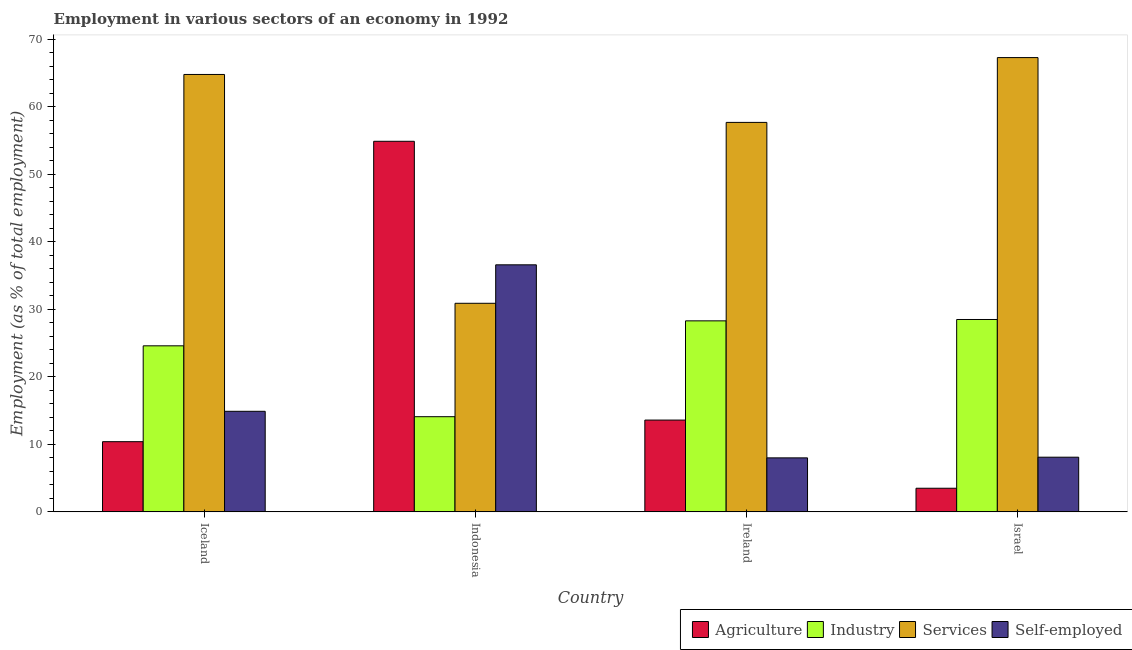Are the number of bars per tick equal to the number of legend labels?
Ensure brevity in your answer.  Yes. Are the number of bars on each tick of the X-axis equal?
Your answer should be compact. Yes. How many bars are there on the 3rd tick from the left?
Ensure brevity in your answer.  4. What is the label of the 4th group of bars from the left?
Your answer should be very brief. Israel. In how many cases, is the number of bars for a given country not equal to the number of legend labels?
Offer a very short reply. 0. What is the percentage of self employed workers in Iceland?
Your response must be concise. 14.9. Across all countries, what is the maximum percentage of workers in services?
Your answer should be compact. 67.3. Across all countries, what is the minimum percentage of workers in services?
Offer a very short reply. 30.9. In which country was the percentage of self employed workers maximum?
Provide a short and direct response. Indonesia. In which country was the percentage of workers in agriculture minimum?
Make the answer very short. Israel. What is the total percentage of workers in agriculture in the graph?
Ensure brevity in your answer.  82.4. What is the difference between the percentage of workers in services in Indonesia and that in Ireland?
Make the answer very short. -26.8. What is the difference between the percentage of workers in agriculture in Iceland and the percentage of workers in services in Ireland?
Provide a short and direct response. -47.3. What is the average percentage of self employed workers per country?
Provide a succinct answer. 16.9. What is the difference between the percentage of workers in industry and percentage of self employed workers in Ireland?
Ensure brevity in your answer.  20.3. In how many countries, is the percentage of workers in services greater than 16 %?
Keep it short and to the point. 4. What is the ratio of the percentage of workers in industry in Ireland to that in Israel?
Ensure brevity in your answer.  0.99. Is the difference between the percentage of workers in industry in Iceland and Israel greater than the difference between the percentage of workers in services in Iceland and Israel?
Make the answer very short. No. What is the difference between the highest and the second highest percentage of workers in industry?
Offer a terse response. 0.2. What is the difference between the highest and the lowest percentage of workers in agriculture?
Provide a short and direct response. 51.4. Is it the case that in every country, the sum of the percentage of workers in industry and percentage of workers in agriculture is greater than the sum of percentage of workers in services and percentage of self employed workers?
Offer a very short reply. No. What does the 4th bar from the left in Ireland represents?
Offer a very short reply. Self-employed. What does the 2nd bar from the right in Israel represents?
Provide a short and direct response. Services. Are all the bars in the graph horizontal?
Provide a succinct answer. No. Are the values on the major ticks of Y-axis written in scientific E-notation?
Your response must be concise. No. Does the graph contain any zero values?
Give a very brief answer. No. Does the graph contain grids?
Offer a very short reply. No. What is the title of the graph?
Provide a succinct answer. Employment in various sectors of an economy in 1992. Does "SF6 gas" appear as one of the legend labels in the graph?
Make the answer very short. No. What is the label or title of the Y-axis?
Your answer should be very brief. Employment (as % of total employment). What is the Employment (as % of total employment) of Agriculture in Iceland?
Offer a very short reply. 10.4. What is the Employment (as % of total employment) in Industry in Iceland?
Your answer should be very brief. 24.6. What is the Employment (as % of total employment) of Services in Iceland?
Offer a very short reply. 64.8. What is the Employment (as % of total employment) in Self-employed in Iceland?
Your answer should be very brief. 14.9. What is the Employment (as % of total employment) in Agriculture in Indonesia?
Provide a short and direct response. 54.9. What is the Employment (as % of total employment) in Industry in Indonesia?
Ensure brevity in your answer.  14.1. What is the Employment (as % of total employment) of Services in Indonesia?
Your answer should be very brief. 30.9. What is the Employment (as % of total employment) in Self-employed in Indonesia?
Offer a terse response. 36.6. What is the Employment (as % of total employment) in Agriculture in Ireland?
Keep it short and to the point. 13.6. What is the Employment (as % of total employment) in Industry in Ireland?
Provide a succinct answer. 28.3. What is the Employment (as % of total employment) in Services in Ireland?
Offer a terse response. 57.7. What is the Employment (as % of total employment) of Self-employed in Ireland?
Make the answer very short. 8. What is the Employment (as % of total employment) of Agriculture in Israel?
Offer a terse response. 3.5. What is the Employment (as % of total employment) in Industry in Israel?
Ensure brevity in your answer.  28.5. What is the Employment (as % of total employment) in Services in Israel?
Offer a terse response. 67.3. What is the Employment (as % of total employment) in Self-employed in Israel?
Your answer should be very brief. 8.1. Across all countries, what is the maximum Employment (as % of total employment) of Agriculture?
Provide a short and direct response. 54.9. Across all countries, what is the maximum Employment (as % of total employment) in Services?
Keep it short and to the point. 67.3. Across all countries, what is the maximum Employment (as % of total employment) of Self-employed?
Keep it short and to the point. 36.6. Across all countries, what is the minimum Employment (as % of total employment) in Industry?
Ensure brevity in your answer.  14.1. Across all countries, what is the minimum Employment (as % of total employment) in Services?
Offer a very short reply. 30.9. Across all countries, what is the minimum Employment (as % of total employment) in Self-employed?
Your answer should be compact. 8. What is the total Employment (as % of total employment) of Agriculture in the graph?
Give a very brief answer. 82.4. What is the total Employment (as % of total employment) of Industry in the graph?
Ensure brevity in your answer.  95.5. What is the total Employment (as % of total employment) of Services in the graph?
Your response must be concise. 220.7. What is the total Employment (as % of total employment) of Self-employed in the graph?
Offer a very short reply. 67.6. What is the difference between the Employment (as % of total employment) in Agriculture in Iceland and that in Indonesia?
Provide a succinct answer. -44.5. What is the difference between the Employment (as % of total employment) in Industry in Iceland and that in Indonesia?
Your answer should be very brief. 10.5. What is the difference between the Employment (as % of total employment) in Services in Iceland and that in Indonesia?
Keep it short and to the point. 33.9. What is the difference between the Employment (as % of total employment) of Self-employed in Iceland and that in Indonesia?
Give a very brief answer. -21.7. What is the difference between the Employment (as % of total employment) of Agriculture in Iceland and that in Ireland?
Keep it short and to the point. -3.2. What is the difference between the Employment (as % of total employment) of Services in Iceland and that in Ireland?
Make the answer very short. 7.1. What is the difference between the Employment (as % of total employment) of Self-employed in Iceland and that in Ireland?
Your response must be concise. 6.9. What is the difference between the Employment (as % of total employment) in Industry in Iceland and that in Israel?
Offer a very short reply. -3.9. What is the difference between the Employment (as % of total employment) in Services in Iceland and that in Israel?
Give a very brief answer. -2.5. What is the difference between the Employment (as % of total employment) in Self-employed in Iceland and that in Israel?
Make the answer very short. 6.8. What is the difference between the Employment (as % of total employment) in Agriculture in Indonesia and that in Ireland?
Your answer should be very brief. 41.3. What is the difference between the Employment (as % of total employment) of Industry in Indonesia and that in Ireland?
Provide a succinct answer. -14.2. What is the difference between the Employment (as % of total employment) in Services in Indonesia and that in Ireland?
Ensure brevity in your answer.  -26.8. What is the difference between the Employment (as % of total employment) of Self-employed in Indonesia and that in Ireland?
Your answer should be very brief. 28.6. What is the difference between the Employment (as % of total employment) in Agriculture in Indonesia and that in Israel?
Your answer should be very brief. 51.4. What is the difference between the Employment (as % of total employment) of Industry in Indonesia and that in Israel?
Your answer should be very brief. -14.4. What is the difference between the Employment (as % of total employment) of Services in Indonesia and that in Israel?
Your answer should be very brief. -36.4. What is the difference between the Employment (as % of total employment) of Industry in Ireland and that in Israel?
Make the answer very short. -0.2. What is the difference between the Employment (as % of total employment) of Services in Ireland and that in Israel?
Make the answer very short. -9.6. What is the difference between the Employment (as % of total employment) in Agriculture in Iceland and the Employment (as % of total employment) in Services in Indonesia?
Provide a succinct answer. -20.5. What is the difference between the Employment (as % of total employment) of Agriculture in Iceland and the Employment (as % of total employment) of Self-employed in Indonesia?
Make the answer very short. -26.2. What is the difference between the Employment (as % of total employment) of Industry in Iceland and the Employment (as % of total employment) of Self-employed in Indonesia?
Provide a succinct answer. -12. What is the difference between the Employment (as % of total employment) in Services in Iceland and the Employment (as % of total employment) in Self-employed in Indonesia?
Offer a very short reply. 28.2. What is the difference between the Employment (as % of total employment) of Agriculture in Iceland and the Employment (as % of total employment) of Industry in Ireland?
Keep it short and to the point. -17.9. What is the difference between the Employment (as % of total employment) in Agriculture in Iceland and the Employment (as % of total employment) in Services in Ireland?
Your answer should be compact. -47.3. What is the difference between the Employment (as % of total employment) of Agriculture in Iceland and the Employment (as % of total employment) of Self-employed in Ireland?
Offer a terse response. 2.4. What is the difference between the Employment (as % of total employment) in Industry in Iceland and the Employment (as % of total employment) in Services in Ireland?
Ensure brevity in your answer.  -33.1. What is the difference between the Employment (as % of total employment) in Services in Iceland and the Employment (as % of total employment) in Self-employed in Ireland?
Your response must be concise. 56.8. What is the difference between the Employment (as % of total employment) of Agriculture in Iceland and the Employment (as % of total employment) of Industry in Israel?
Give a very brief answer. -18.1. What is the difference between the Employment (as % of total employment) in Agriculture in Iceland and the Employment (as % of total employment) in Services in Israel?
Offer a terse response. -56.9. What is the difference between the Employment (as % of total employment) of Industry in Iceland and the Employment (as % of total employment) of Services in Israel?
Ensure brevity in your answer.  -42.7. What is the difference between the Employment (as % of total employment) of Services in Iceland and the Employment (as % of total employment) of Self-employed in Israel?
Your answer should be compact. 56.7. What is the difference between the Employment (as % of total employment) in Agriculture in Indonesia and the Employment (as % of total employment) in Industry in Ireland?
Keep it short and to the point. 26.6. What is the difference between the Employment (as % of total employment) of Agriculture in Indonesia and the Employment (as % of total employment) of Services in Ireland?
Give a very brief answer. -2.8. What is the difference between the Employment (as % of total employment) of Agriculture in Indonesia and the Employment (as % of total employment) of Self-employed in Ireland?
Your answer should be compact. 46.9. What is the difference between the Employment (as % of total employment) in Industry in Indonesia and the Employment (as % of total employment) in Services in Ireland?
Provide a short and direct response. -43.6. What is the difference between the Employment (as % of total employment) of Industry in Indonesia and the Employment (as % of total employment) of Self-employed in Ireland?
Offer a terse response. 6.1. What is the difference between the Employment (as % of total employment) in Services in Indonesia and the Employment (as % of total employment) in Self-employed in Ireland?
Provide a succinct answer. 22.9. What is the difference between the Employment (as % of total employment) of Agriculture in Indonesia and the Employment (as % of total employment) of Industry in Israel?
Ensure brevity in your answer.  26.4. What is the difference between the Employment (as % of total employment) in Agriculture in Indonesia and the Employment (as % of total employment) in Self-employed in Israel?
Give a very brief answer. 46.8. What is the difference between the Employment (as % of total employment) of Industry in Indonesia and the Employment (as % of total employment) of Services in Israel?
Your answer should be compact. -53.2. What is the difference between the Employment (as % of total employment) of Services in Indonesia and the Employment (as % of total employment) of Self-employed in Israel?
Offer a very short reply. 22.8. What is the difference between the Employment (as % of total employment) in Agriculture in Ireland and the Employment (as % of total employment) in Industry in Israel?
Offer a very short reply. -14.9. What is the difference between the Employment (as % of total employment) of Agriculture in Ireland and the Employment (as % of total employment) of Services in Israel?
Provide a succinct answer. -53.7. What is the difference between the Employment (as % of total employment) in Agriculture in Ireland and the Employment (as % of total employment) in Self-employed in Israel?
Make the answer very short. 5.5. What is the difference between the Employment (as % of total employment) of Industry in Ireland and the Employment (as % of total employment) of Services in Israel?
Give a very brief answer. -39. What is the difference between the Employment (as % of total employment) in Industry in Ireland and the Employment (as % of total employment) in Self-employed in Israel?
Give a very brief answer. 20.2. What is the difference between the Employment (as % of total employment) in Services in Ireland and the Employment (as % of total employment) in Self-employed in Israel?
Make the answer very short. 49.6. What is the average Employment (as % of total employment) in Agriculture per country?
Give a very brief answer. 20.6. What is the average Employment (as % of total employment) of Industry per country?
Your answer should be very brief. 23.88. What is the average Employment (as % of total employment) in Services per country?
Give a very brief answer. 55.17. What is the difference between the Employment (as % of total employment) in Agriculture and Employment (as % of total employment) in Industry in Iceland?
Your response must be concise. -14.2. What is the difference between the Employment (as % of total employment) of Agriculture and Employment (as % of total employment) of Services in Iceland?
Offer a terse response. -54.4. What is the difference between the Employment (as % of total employment) in Agriculture and Employment (as % of total employment) in Self-employed in Iceland?
Provide a short and direct response. -4.5. What is the difference between the Employment (as % of total employment) of Industry and Employment (as % of total employment) of Services in Iceland?
Give a very brief answer. -40.2. What is the difference between the Employment (as % of total employment) in Industry and Employment (as % of total employment) in Self-employed in Iceland?
Your response must be concise. 9.7. What is the difference between the Employment (as % of total employment) of Services and Employment (as % of total employment) of Self-employed in Iceland?
Your response must be concise. 49.9. What is the difference between the Employment (as % of total employment) in Agriculture and Employment (as % of total employment) in Industry in Indonesia?
Give a very brief answer. 40.8. What is the difference between the Employment (as % of total employment) in Agriculture and Employment (as % of total employment) in Self-employed in Indonesia?
Make the answer very short. 18.3. What is the difference between the Employment (as % of total employment) of Industry and Employment (as % of total employment) of Services in Indonesia?
Your response must be concise. -16.8. What is the difference between the Employment (as % of total employment) of Industry and Employment (as % of total employment) of Self-employed in Indonesia?
Your answer should be very brief. -22.5. What is the difference between the Employment (as % of total employment) of Agriculture and Employment (as % of total employment) of Industry in Ireland?
Make the answer very short. -14.7. What is the difference between the Employment (as % of total employment) of Agriculture and Employment (as % of total employment) of Services in Ireland?
Provide a short and direct response. -44.1. What is the difference between the Employment (as % of total employment) of Agriculture and Employment (as % of total employment) of Self-employed in Ireland?
Keep it short and to the point. 5.6. What is the difference between the Employment (as % of total employment) of Industry and Employment (as % of total employment) of Services in Ireland?
Ensure brevity in your answer.  -29.4. What is the difference between the Employment (as % of total employment) in Industry and Employment (as % of total employment) in Self-employed in Ireland?
Provide a short and direct response. 20.3. What is the difference between the Employment (as % of total employment) in Services and Employment (as % of total employment) in Self-employed in Ireland?
Provide a succinct answer. 49.7. What is the difference between the Employment (as % of total employment) of Agriculture and Employment (as % of total employment) of Services in Israel?
Give a very brief answer. -63.8. What is the difference between the Employment (as % of total employment) of Agriculture and Employment (as % of total employment) of Self-employed in Israel?
Ensure brevity in your answer.  -4.6. What is the difference between the Employment (as % of total employment) in Industry and Employment (as % of total employment) in Services in Israel?
Offer a very short reply. -38.8. What is the difference between the Employment (as % of total employment) in Industry and Employment (as % of total employment) in Self-employed in Israel?
Provide a succinct answer. 20.4. What is the difference between the Employment (as % of total employment) in Services and Employment (as % of total employment) in Self-employed in Israel?
Your response must be concise. 59.2. What is the ratio of the Employment (as % of total employment) of Agriculture in Iceland to that in Indonesia?
Give a very brief answer. 0.19. What is the ratio of the Employment (as % of total employment) in Industry in Iceland to that in Indonesia?
Offer a very short reply. 1.74. What is the ratio of the Employment (as % of total employment) of Services in Iceland to that in Indonesia?
Provide a succinct answer. 2.1. What is the ratio of the Employment (as % of total employment) in Self-employed in Iceland to that in Indonesia?
Provide a short and direct response. 0.41. What is the ratio of the Employment (as % of total employment) in Agriculture in Iceland to that in Ireland?
Your response must be concise. 0.76. What is the ratio of the Employment (as % of total employment) of Industry in Iceland to that in Ireland?
Make the answer very short. 0.87. What is the ratio of the Employment (as % of total employment) in Services in Iceland to that in Ireland?
Your answer should be very brief. 1.12. What is the ratio of the Employment (as % of total employment) in Self-employed in Iceland to that in Ireland?
Your answer should be compact. 1.86. What is the ratio of the Employment (as % of total employment) in Agriculture in Iceland to that in Israel?
Provide a succinct answer. 2.97. What is the ratio of the Employment (as % of total employment) in Industry in Iceland to that in Israel?
Make the answer very short. 0.86. What is the ratio of the Employment (as % of total employment) in Services in Iceland to that in Israel?
Offer a very short reply. 0.96. What is the ratio of the Employment (as % of total employment) of Self-employed in Iceland to that in Israel?
Your answer should be compact. 1.84. What is the ratio of the Employment (as % of total employment) of Agriculture in Indonesia to that in Ireland?
Provide a succinct answer. 4.04. What is the ratio of the Employment (as % of total employment) in Industry in Indonesia to that in Ireland?
Ensure brevity in your answer.  0.5. What is the ratio of the Employment (as % of total employment) of Services in Indonesia to that in Ireland?
Offer a very short reply. 0.54. What is the ratio of the Employment (as % of total employment) of Self-employed in Indonesia to that in Ireland?
Your answer should be very brief. 4.58. What is the ratio of the Employment (as % of total employment) in Agriculture in Indonesia to that in Israel?
Your answer should be compact. 15.69. What is the ratio of the Employment (as % of total employment) of Industry in Indonesia to that in Israel?
Make the answer very short. 0.49. What is the ratio of the Employment (as % of total employment) of Services in Indonesia to that in Israel?
Provide a succinct answer. 0.46. What is the ratio of the Employment (as % of total employment) in Self-employed in Indonesia to that in Israel?
Your response must be concise. 4.52. What is the ratio of the Employment (as % of total employment) of Agriculture in Ireland to that in Israel?
Keep it short and to the point. 3.89. What is the ratio of the Employment (as % of total employment) in Services in Ireland to that in Israel?
Your answer should be very brief. 0.86. What is the difference between the highest and the second highest Employment (as % of total employment) of Agriculture?
Ensure brevity in your answer.  41.3. What is the difference between the highest and the second highest Employment (as % of total employment) in Services?
Provide a succinct answer. 2.5. What is the difference between the highest and the second highest Employment (as % of total employment) in Self-employed?
Make the answer very short. 21.7. What is the difference between the highest and the lowest Employment (as % of total employment) in Agriculture?
Ensure brevity in your answer.  51.4. What is the difference between the highest and the lowest Employment (as % of total employment) in Industry?
Ensure brevity in your answer.  14.4. What is the difference between the highest and the lowest Employment (as % of total employment) in Services?
Offer a very short reply. 36.4. What is the difference between the highest and the lowest Employment (as % of total employment) in Self-employed?
Offer a terse response. 28.6. 